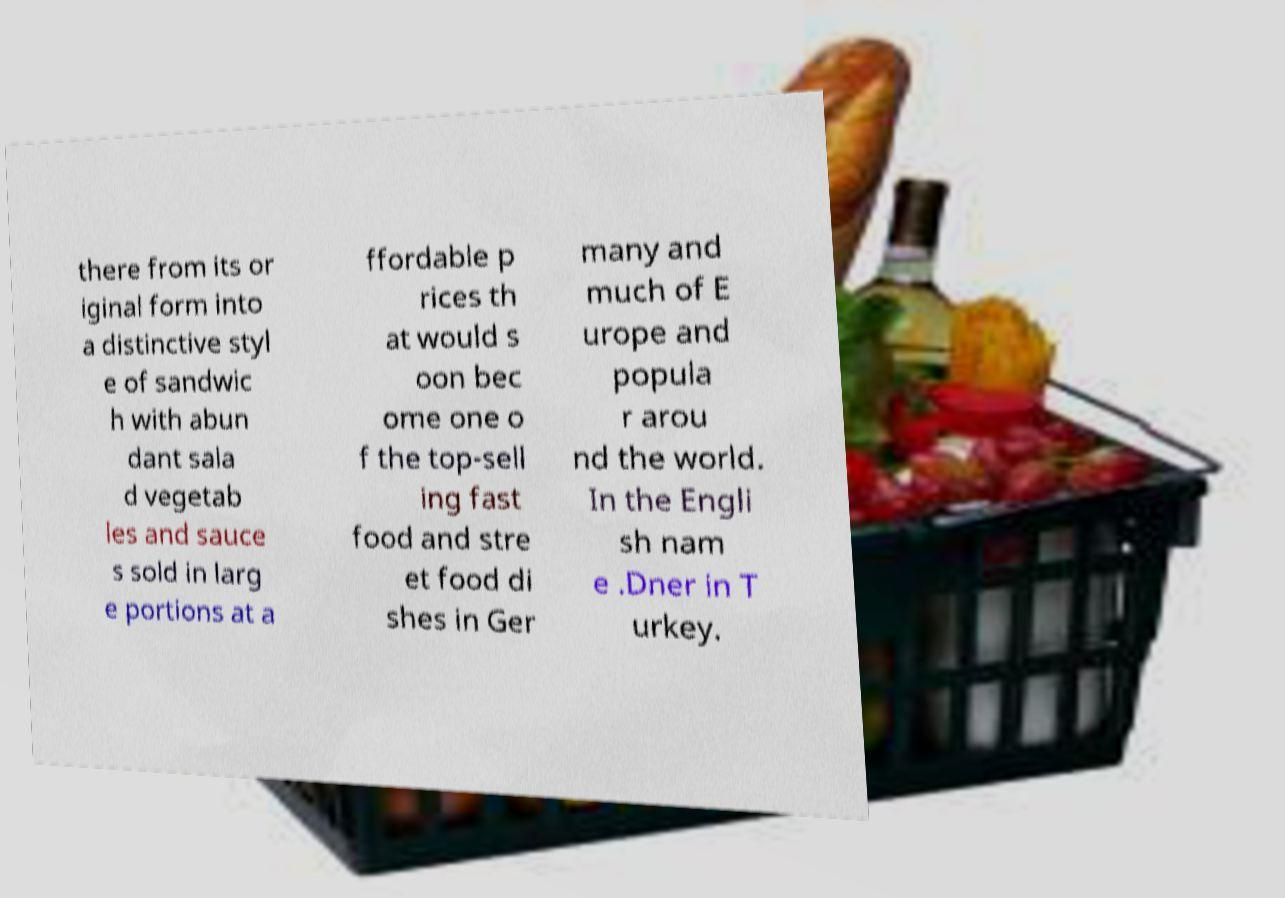Can you read and provide the text displayed in the image?This photo seems to have some interesting text. Can you extract and type it out for me? there from its or iginal form into a distinctive styl e of sandwic h with abun dant sala d vegetab les and sauce s sold in larg e portions at a ffordable p rices th at would s oon bec ome one o f the top-sell ing fast food and stre et food di shes in Ger many and much of E urope and popula r arou nd the world. In the Engli sh nam e .Dner in T urkey. 